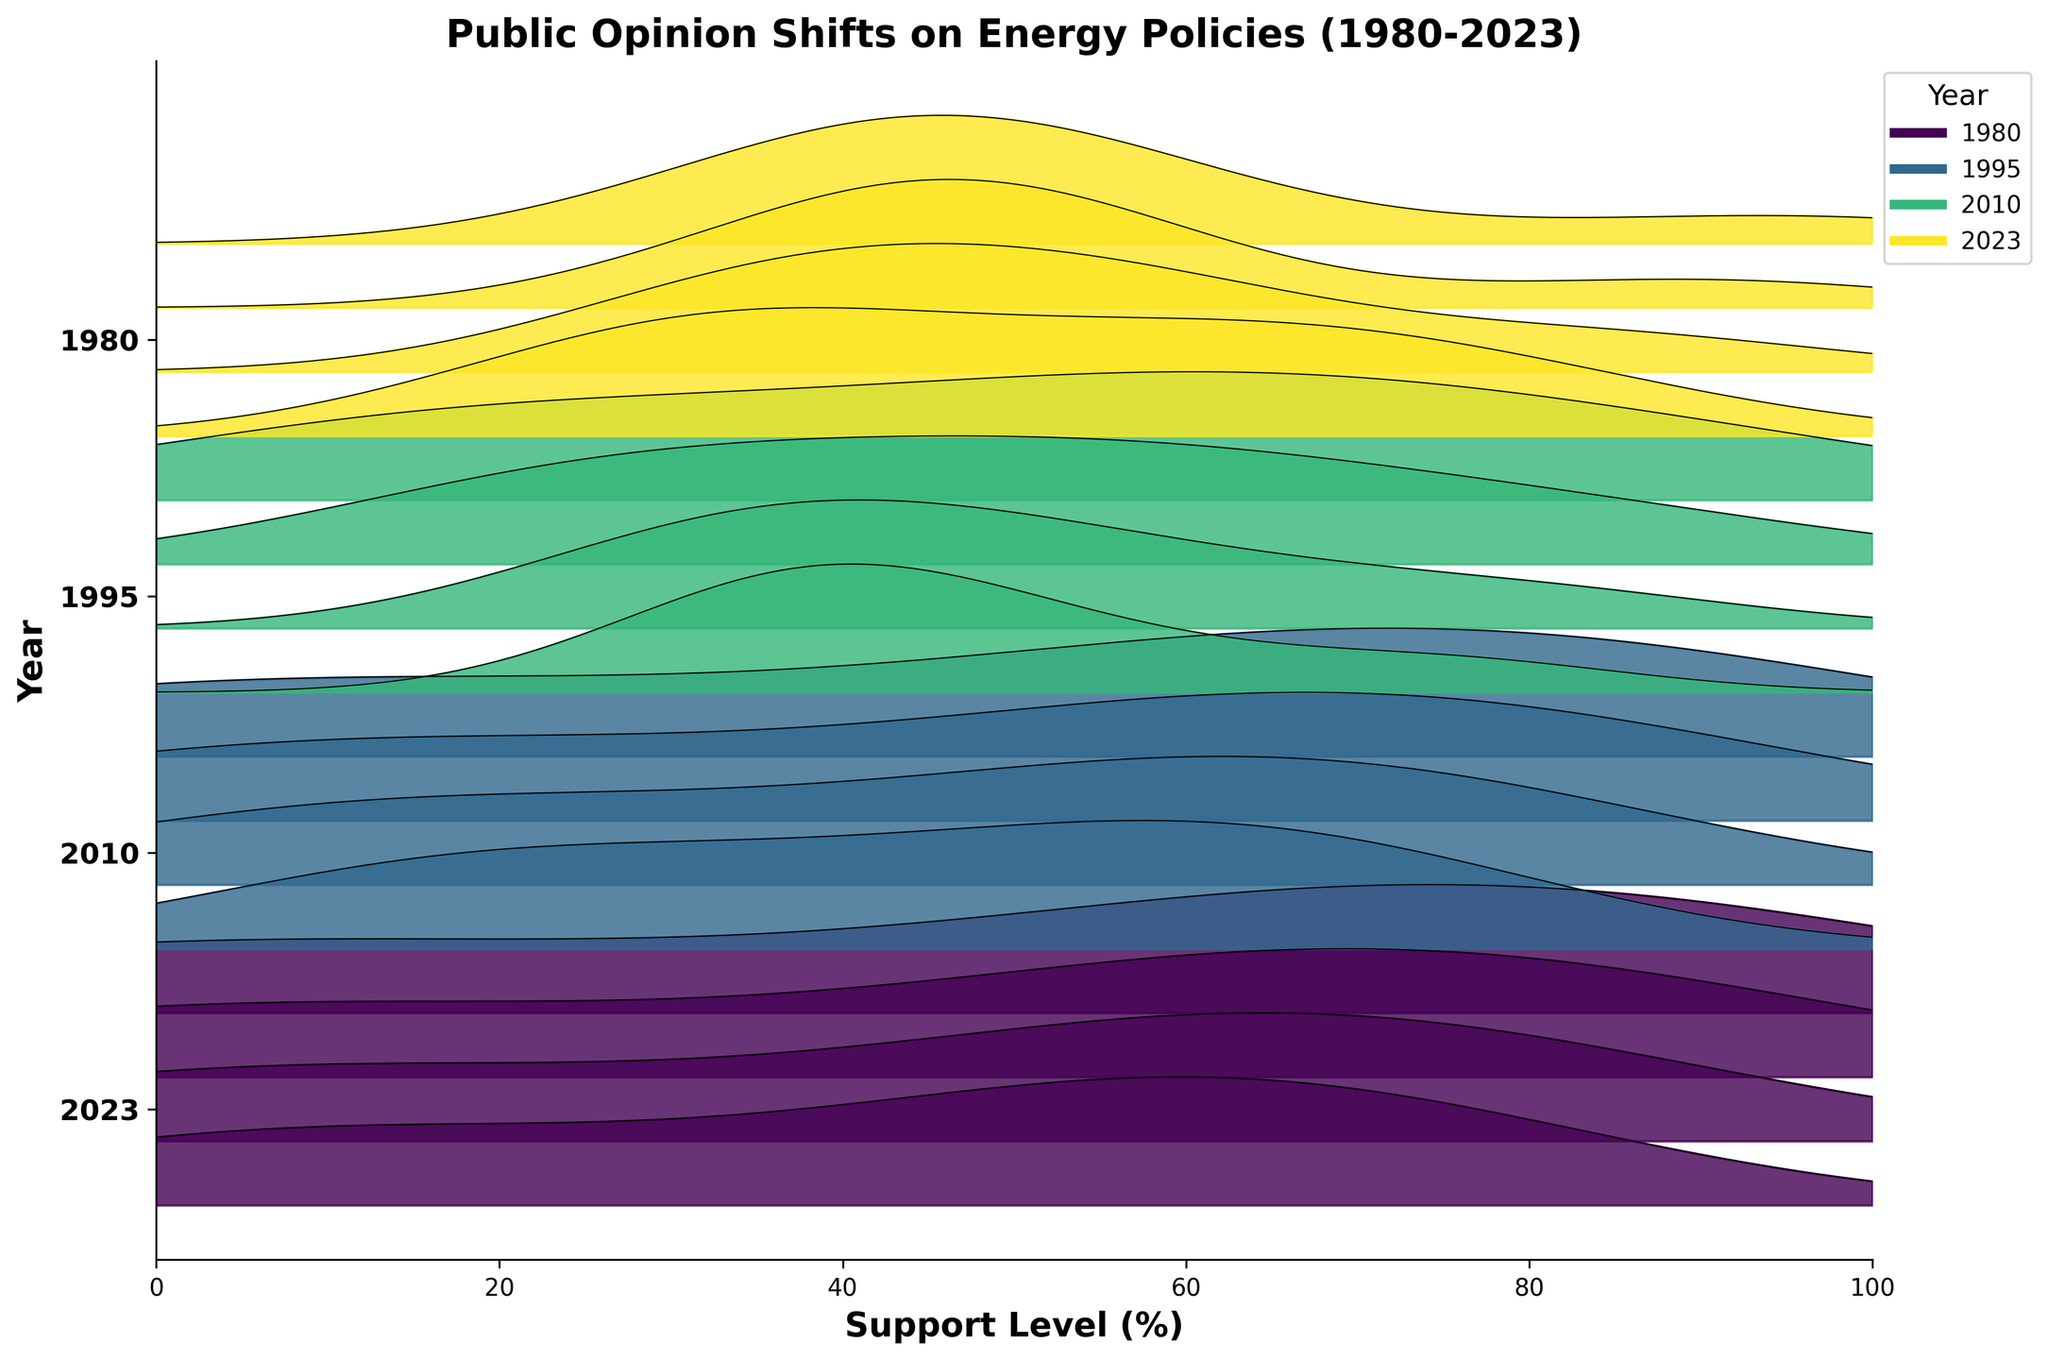What's the title of the figure? The title is written at the top of the figure and summarizes the overall content.
Answer: Public Opinion Shifts on Energy Policies (1980-2023) What are the x-axis and y-axis labels? The x-axis label is written at the bottom of the horizontal axis, and the y-axis label is written along the vertical axis.
Answer: Support Level (%) and Year Which age group shows the highest support for coal in 1980? By comparing the density peaks for coal in 1980 across different age groups, we can determine the highest support found in the 60+ age group.
Answer: 60+ age group How does the support for solar energy in the 18-29 age group change from 1980 to 2023? Compare the density peaks for solar energy for the 18-29 age group across the years 1980, 1995, 2010, and 2023, noticing an increase over time.
Answer: An increase from 10% to 65% Which year shows the highest support for wind energy among all age groups? Examine the density peaks for wind energy across all years; the highest peak will indicate the year with the highest support. In 2023, the plots show the highest peaks for wind energy.
Answer: 2023 How does the support for natural gas in the 45-59 age group compare between 1995 and 2010? Compare the density peaks for natural gas for the 45-59 age group in both years. The plot shows that support increased from 75% in 1995 to 85% in 2010.
Answer: It increased by 10% Which source of energy has the lowest support in 2023 across all age groups? Examine the density peaks for all energy sources in 2023; the lowest peaks indicate the least supported source, which is oil.
Answer: Oil Has the support for nuclear energy increased or decreased over time for the 18-29 age group? Compare the density peaks for nuclear energy for the 18-29 age group in 1980, 1995, 2010, and 2023. The plots show a decrease over time.
Answer: Decreased In which age group does oil have the highest support in 2010? By measuring the density peaks for oil in 2010 across different age groups, the highest is found in the 60+ age group.
Answer: 60+ age group What's the difference in support for natural gas between the youngest and oldest age groups in 2023? Compare the density peaks of natural gas for the 18-29 and 60+ age groups showing natural gas support of 80% for the youngest and 95% for the oldest, resulting in a difference of 15%.
Answer: 15% 